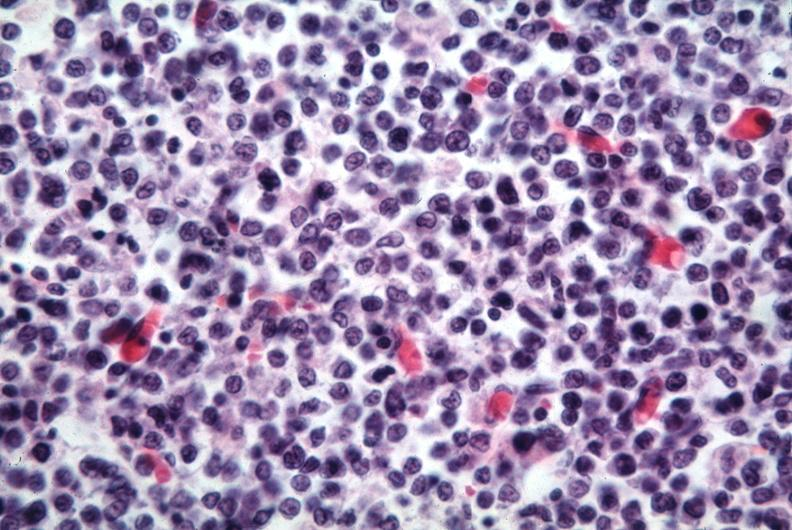s lymph node present?
Answer the question using a single word or phrase. Yes 